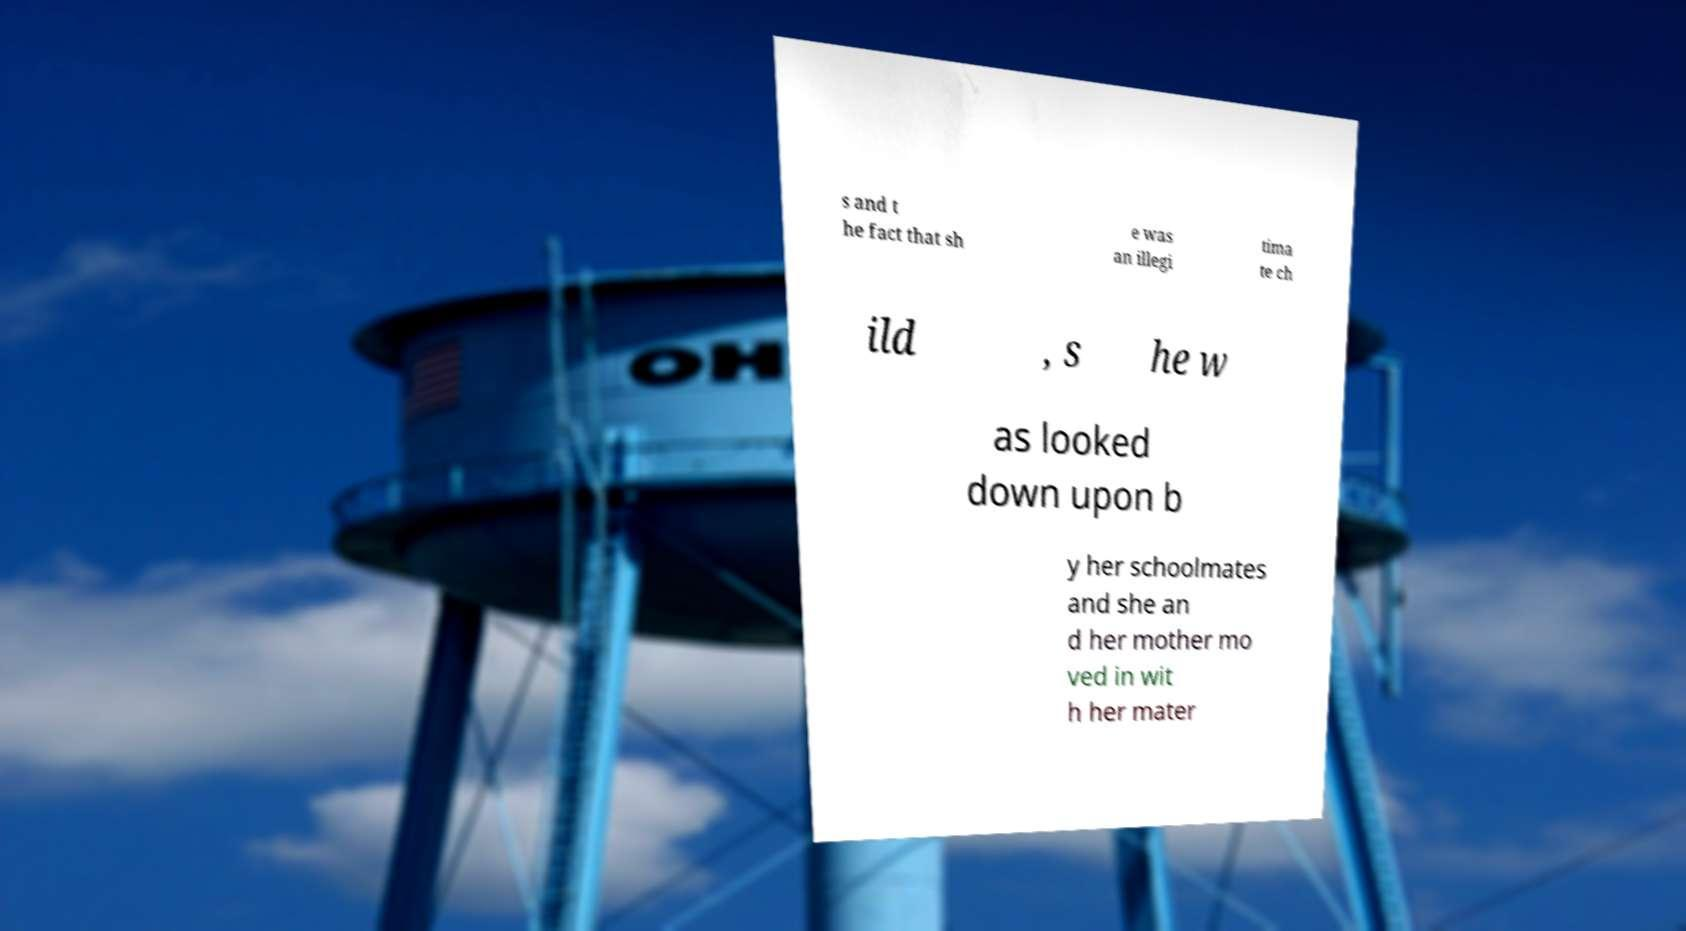There's text embedded in this image that I need extracted. Can you transcribe it verbatim? s and t he fact that sh e was an illegi tima te ch ild , s he w as looked down upon b y her schoolmates and she an d her mother mo ved in wit h her mater 